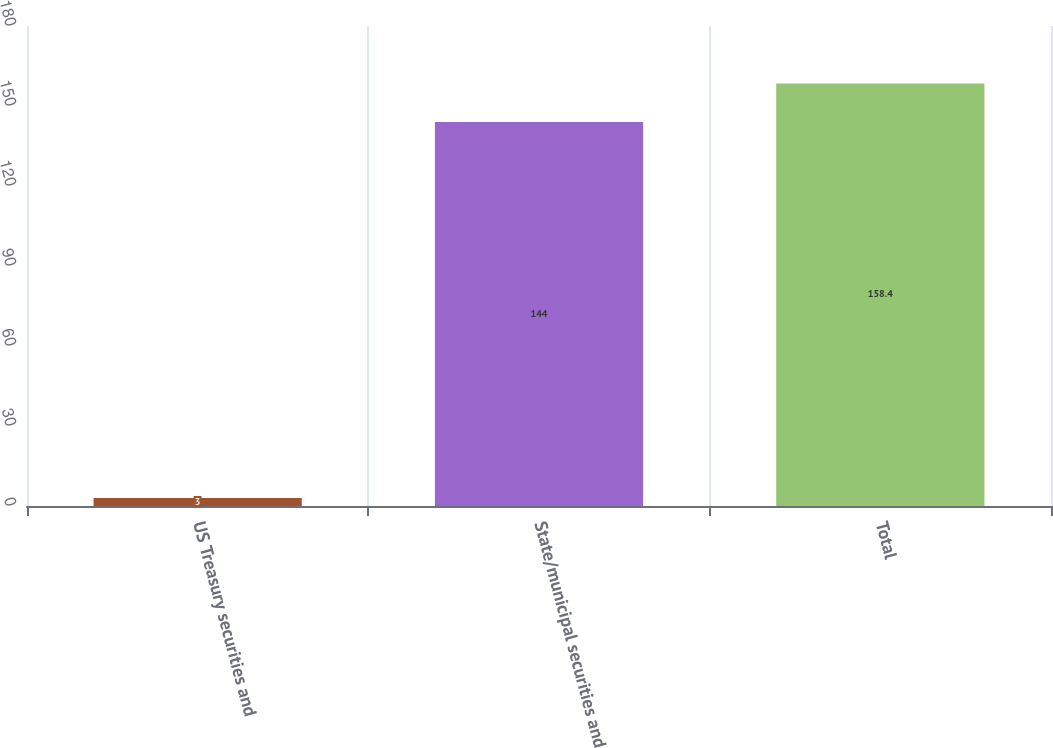Convert chart. <chart><loc_0><loc_0><loc_500><loc_500><bar_chart><fcel>US Treasury securities and<fcel>State/municipal securities and<fcel>Total<nl><fcel>3<fcel>144<fcel>158.4<nl></chart> 